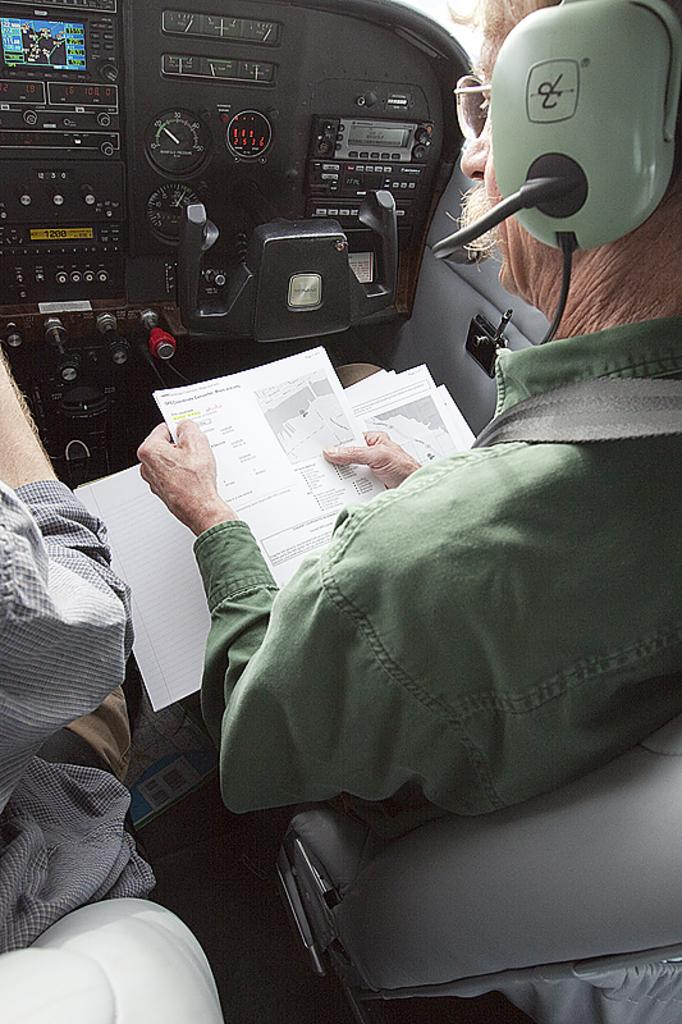How many people are in the image? There are people in the image. What are the people doing in the image? The people are seated. Can you describe the man on the right side of the image? The man on the right side of the image is wearing a headset and spectacles, and he is holding papers. How many bikes can be seen in the image? There are no bikes visible in the image. What is the man writing on the papers he is holding? The image does not show the man writing on the papers; he is simply holding them. 